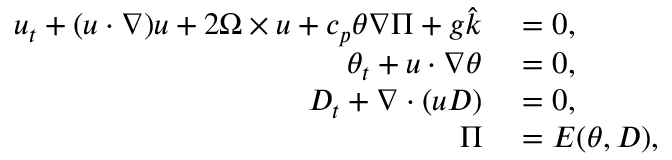Convert formula to latex. <formula><loc_0><loc_0><loc_500><loc_500>\begin{array} { r l } { u _ { t } + ( u \cdot \nabla ) u + 2 \Omega \times u + c _ { p } \theta \nabla \Pi + g \hat { k } } & = 0 , } \\ { \theta _ { t } + u \cdot \nabla \theta } & = 0 , } \\ { D _ { t } + \nabla \cdot ( u D ) } & = 0 , } \\ { \Pi } & = E ( \theta , D ) , } \end{array}</formula> 